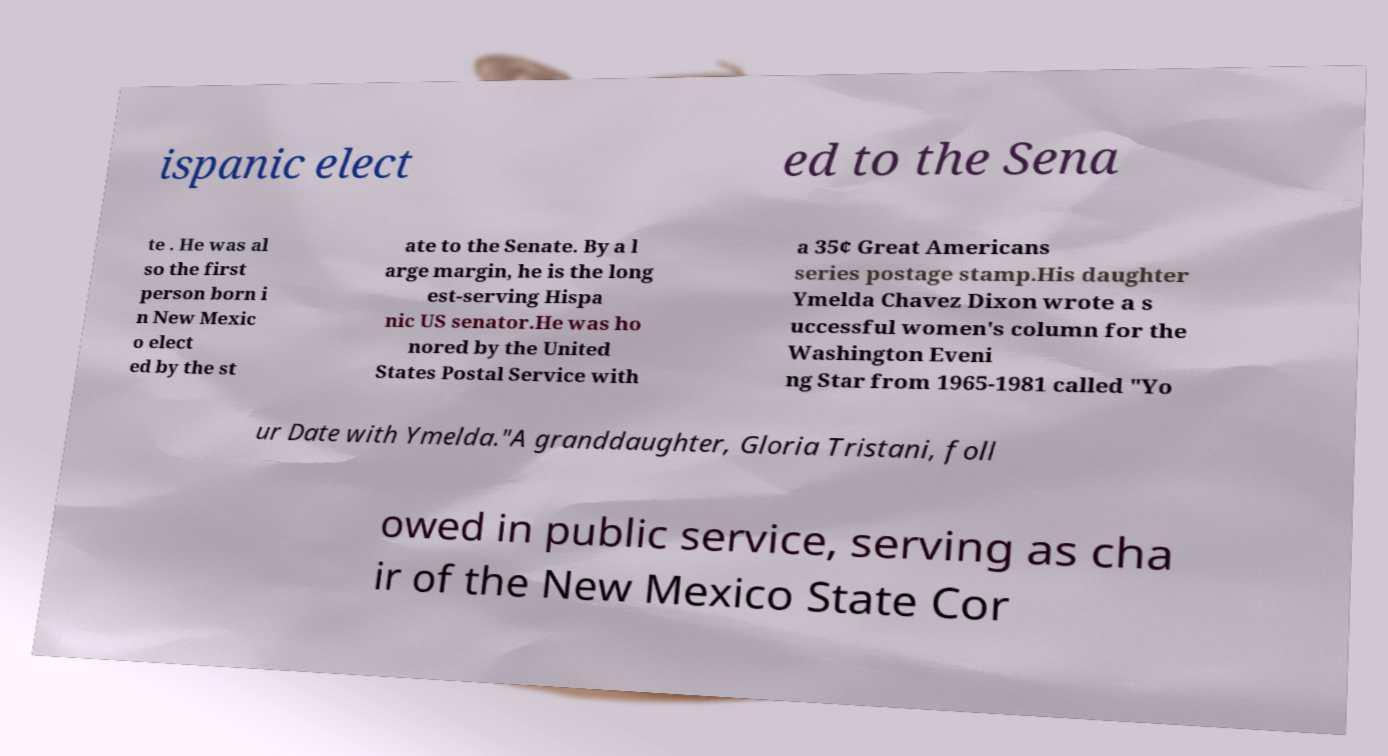For documentation purposes, I need the text within this image transcribed. Could you provide that? ispanic elect ed to the Sena te . He was al so the first person born i n New Mexic o elect ed by the st ate to the Senate. By a l arge margin, he is the long est-serving Hispa nic US senator.He was ho nored by the United States Postal Service with a 35¢ Great Americans series postage stamp.His daughter Ymelda Chavez Dixon wrote a s uccessful women's column for the Washington Eveni ng Star from 1965-1981 called "Yo ur Date with Ymelda."A granddaughter, Gloria Tristani, foll owed in public service, serving as cha ir of the New Mexico State Cor 